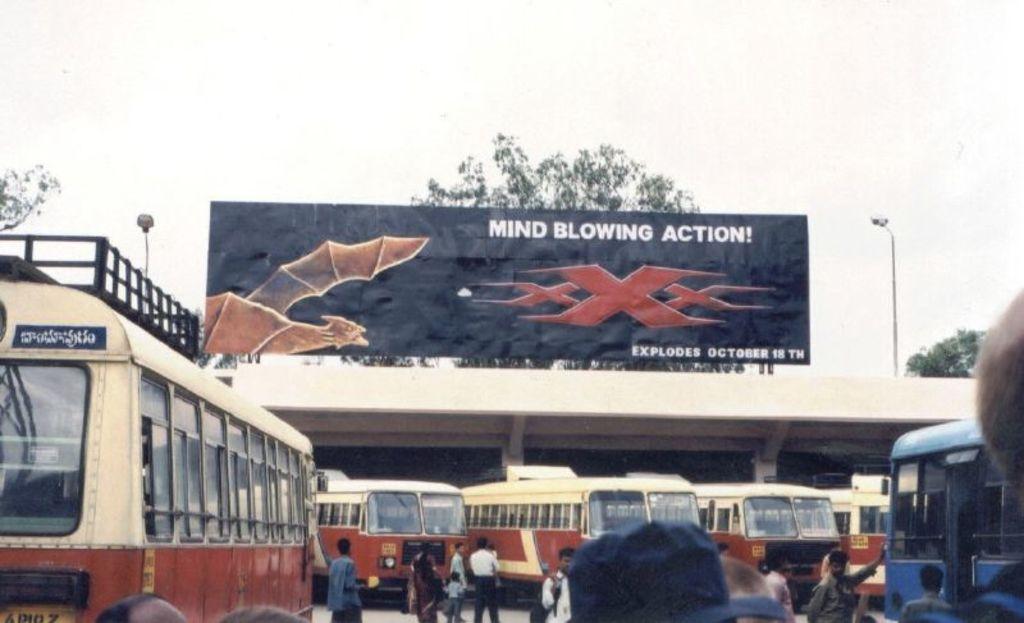Please provide a concise description of this image. In this image in the center there are persons walking and there are vehicles. In the background there is a shelter, on the top of the shelter there is banner with some text written on it and there are trees and poles. 